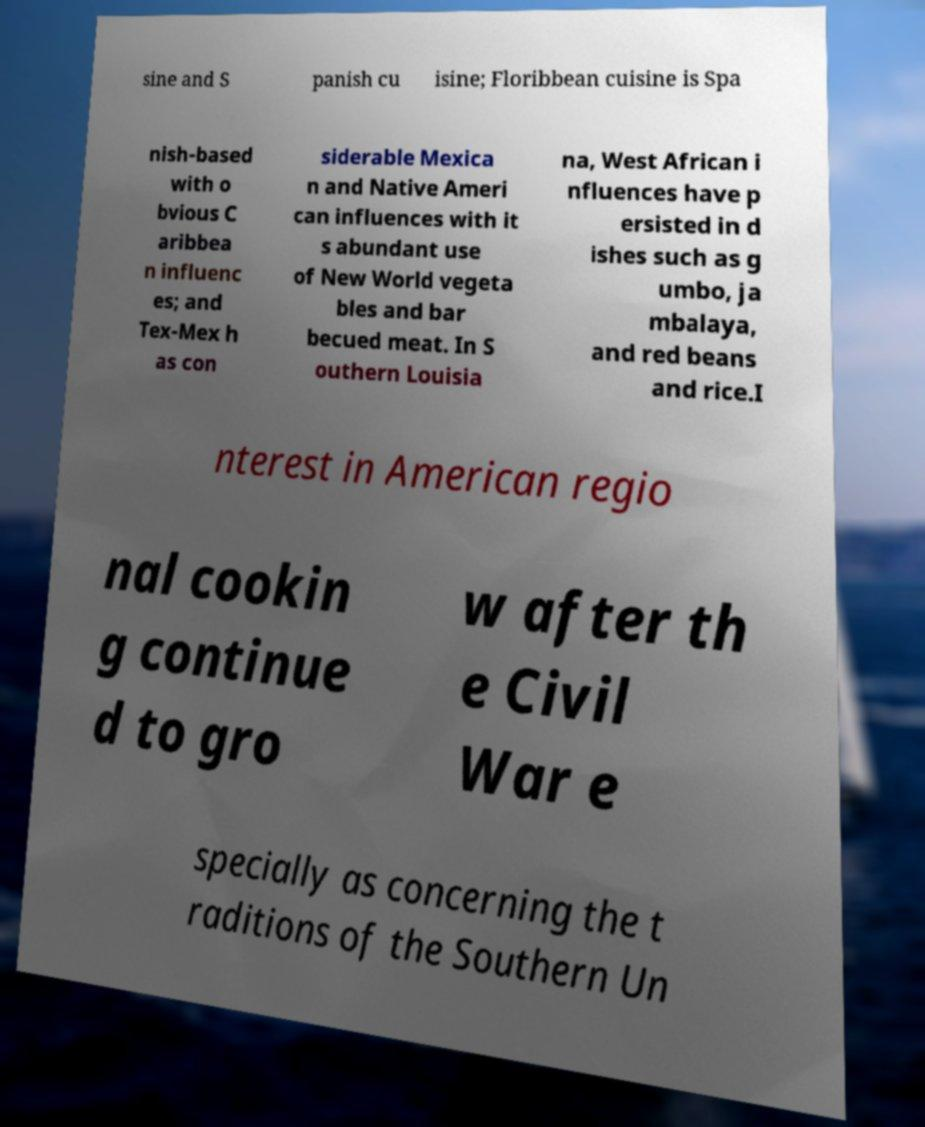I need the written content from this picture converted into text. Can you do that? sine and S panish cu isine; Floribbean cuisine is Spa nish-based with o bvious C aribbea n influenc es; and Tex-Mex h as con siderable Mexica n and Native Ameri can influences with it s abundant use of New World vegeta bles and bar becued meat. In S outhern Louisia na, West African i nfluences have p ersisted in d ishes such as g umbo, ja mbalaya, and red beans and rice.I nterest in American regio nal cookin g continue d to gro w after th e Civil War e specially as concerning the t raditions of the Southern Un 